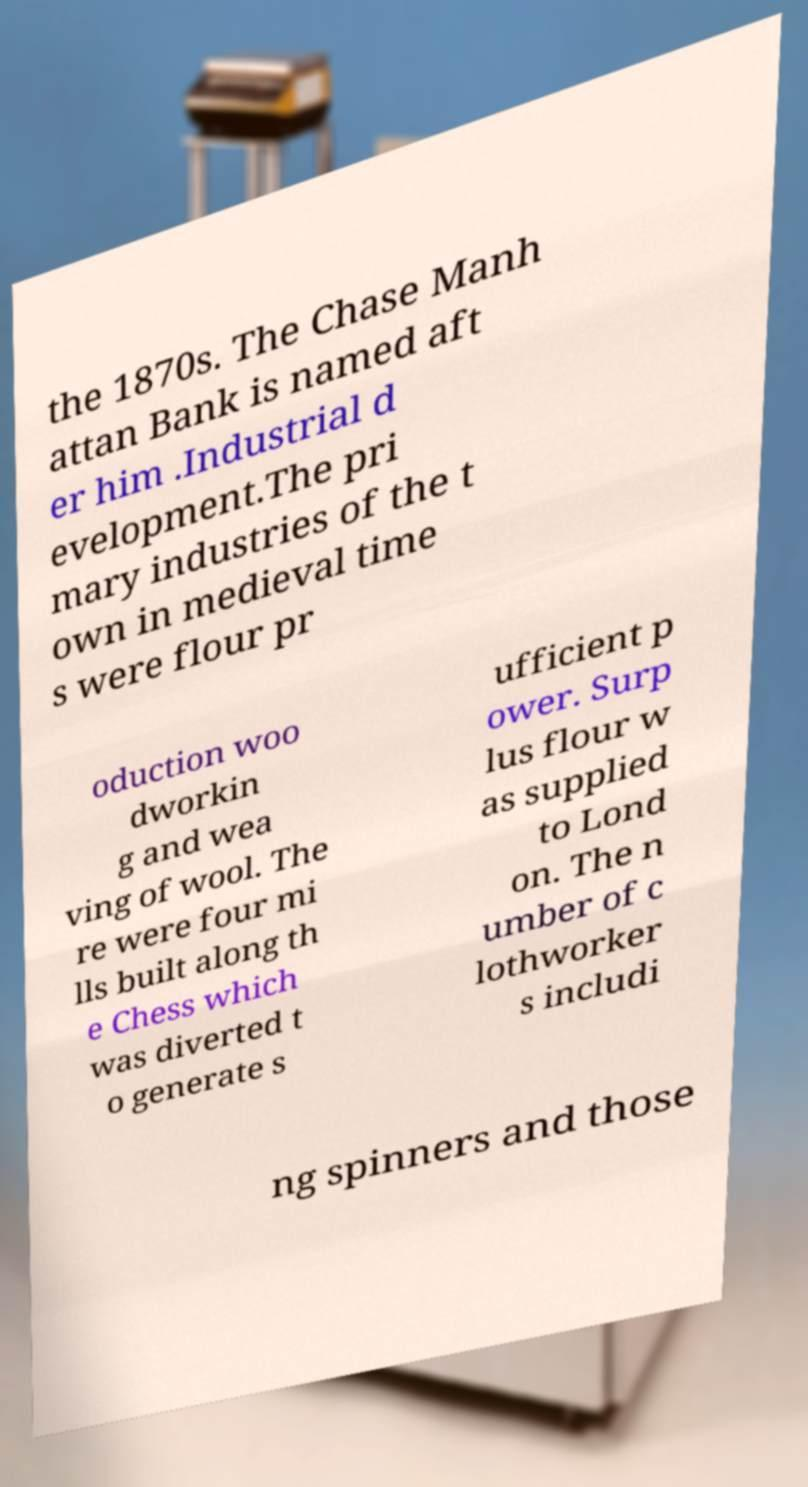Can you accurately transcribe the text from the provided image for me? the 1870s. The Chase Manh attan Bank is named aft er him .Industrial d evelopment.The pri mary industries of the t own in medieval time s were flour pr oduction woo dworkin g and wea ving of wool. The re were four mi lls built along th e Chess which was diverted t o generate s ufficient p ower. Surp lus flour w as supplied to Lond on. The n umber of c lothworker s includi ng spinners and those 